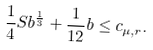Convert formula to latex. <formula><loc_0><loc_0><loc_500><loc_500>\frac { 1 } { 4 } S b ^ { \frac { 1 } { 3 } } + \frac { 1 } { 1 2 } b \leq c _ { \mu , r } .</formula> 